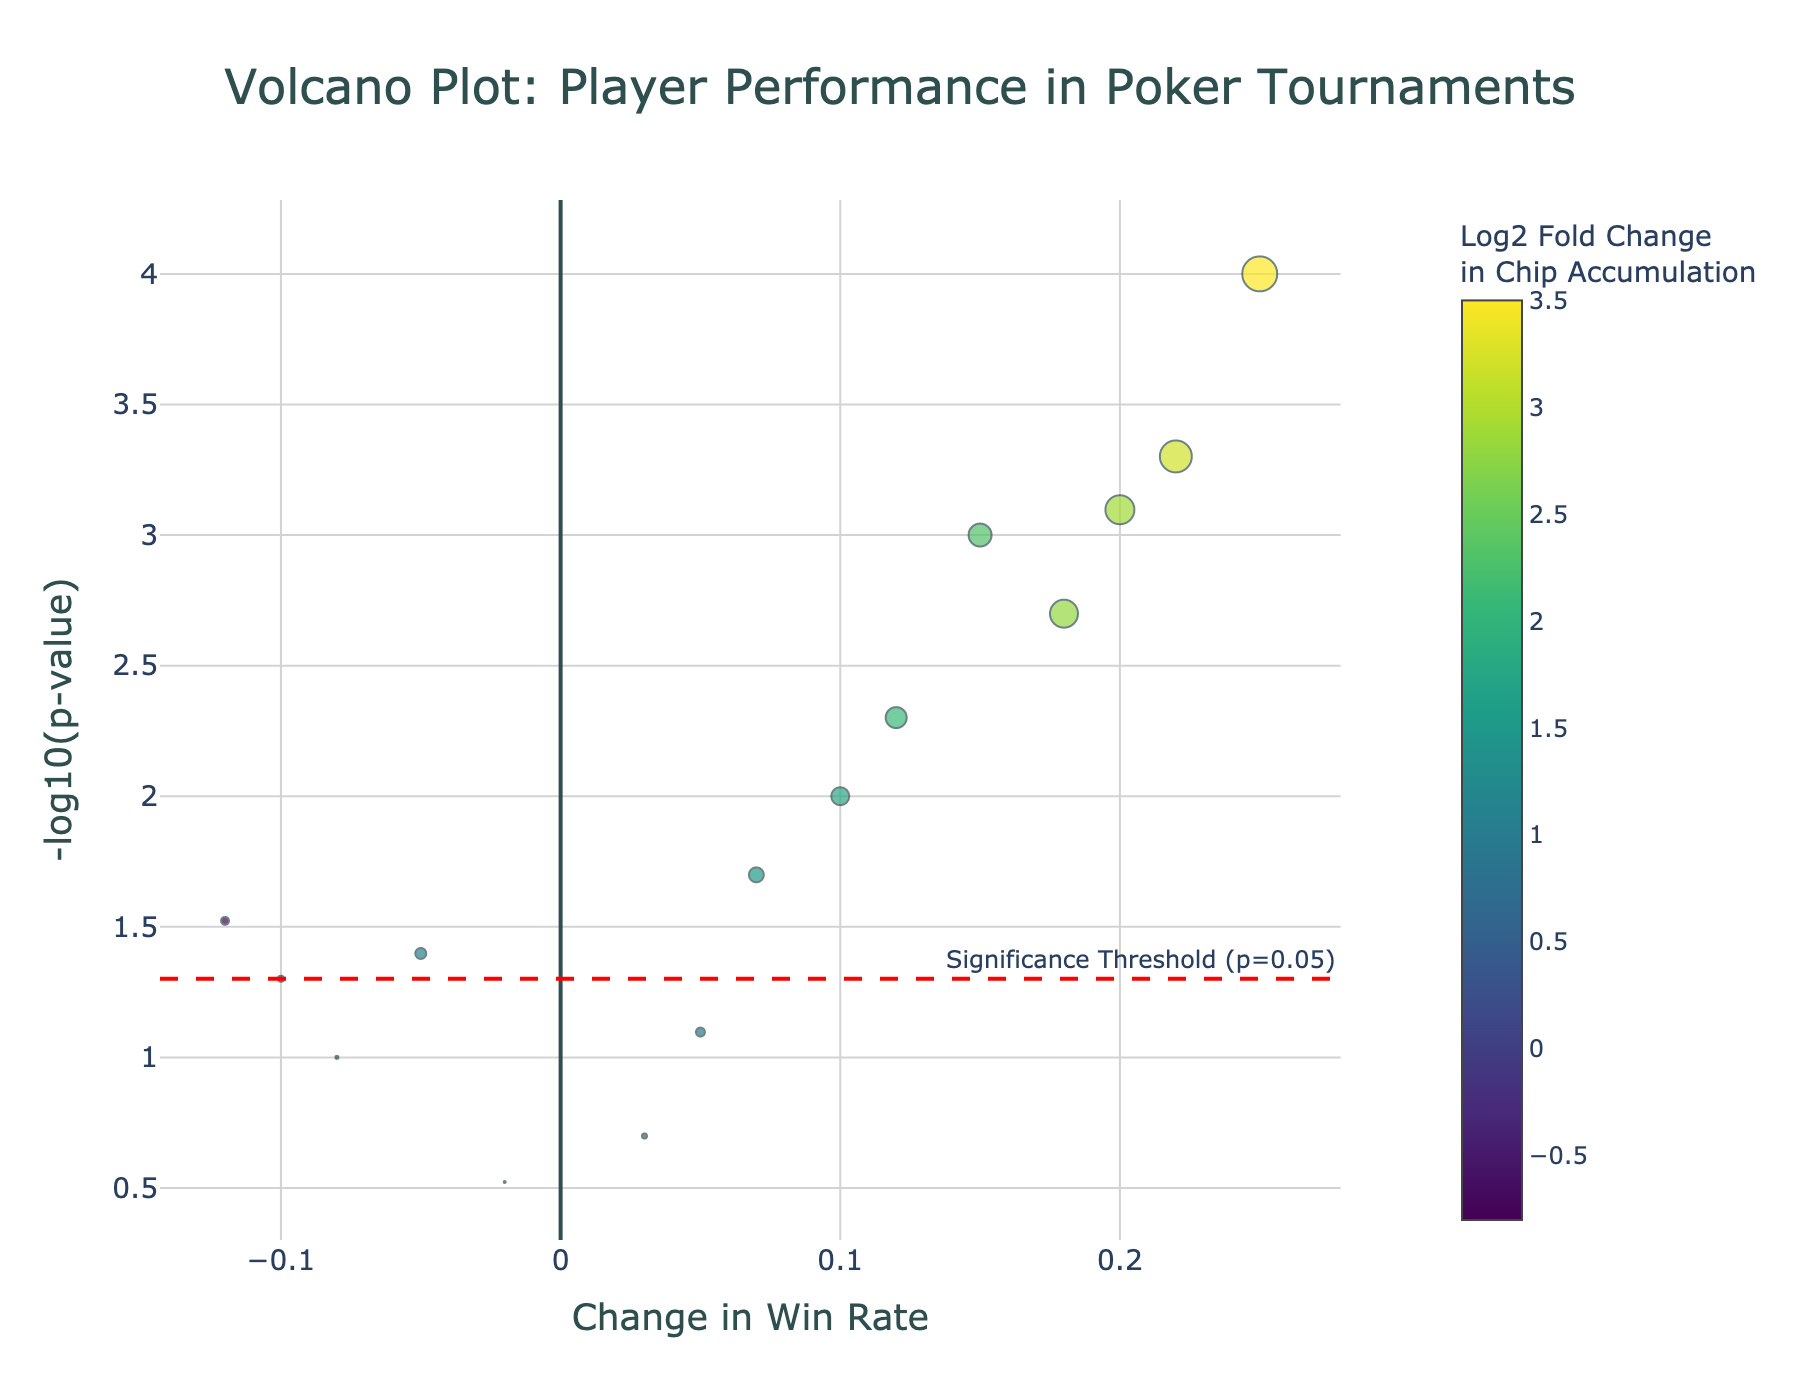What is the title of the figure? The title is found at the top center of the plot. It summarizes the content of the figure.
Answer: Volcano Plot: Player Performance in Poker Tournaments How many players are represented in the plot? Each point represents a player. By counting the total points, you can determine the number of players.
Answer: 15 Which player has the highest -log10(p-value)? To find the player, we look for the point with the highest y-axis value and hover over it to see the player's name in the hover information.
Answer: Bryn Kenney What is the significance threshold for the p-value? A significance threshold line is drawn and annotated within the plot. This line helps to distinguish significant results.
Answer: 0.05 Compare the win rates of Phil Ivey and Daniel Negreanu. Who has a higher win rate change? Phil Ivey's win rate change can be observed as 0.15 while Daniel Negreanu's is -0.05. The value nearer to the positive axis of x is higher.
Answer: Phil Ivey Which player has the highest chip accumulation Log2 Fold Change? The largest-sized point with the greatest color change in the positive direction of Log2 Fold Change indicates the player with the highest chip accumulation.
Answer: Bryn Kenney What is the significance value (p-value) for Stephen Chidwick? By locating Stephen Chidwick’s point and checking the hover information, the p-value can be extracted directly.
Answer: 0.0008 Among the players with negative win rate change, who has the most significant p-value? Look for points with a negative x-axis value and the highest y-axis value (most negative-log-transformed significance). Hover over to identify the player.
Answer: Vanessa Selbst What is the Log2 Fold Change in chip accumulation for Justin Bonomo? Hover over Justin Bonomo’s point to read the hover template, which includes the log2 fold change in chip accumulation.
Answer: 2.8 Is there a relationship between high chip accumulation log2 fold change and win rate increase in the plot? Observing the scatter plot distribution, points generally higher in win rate change (positive x-axis) tend to correspond with larger sizes (indicating high chip accumulation log2 fold change).
Answer: Yes 